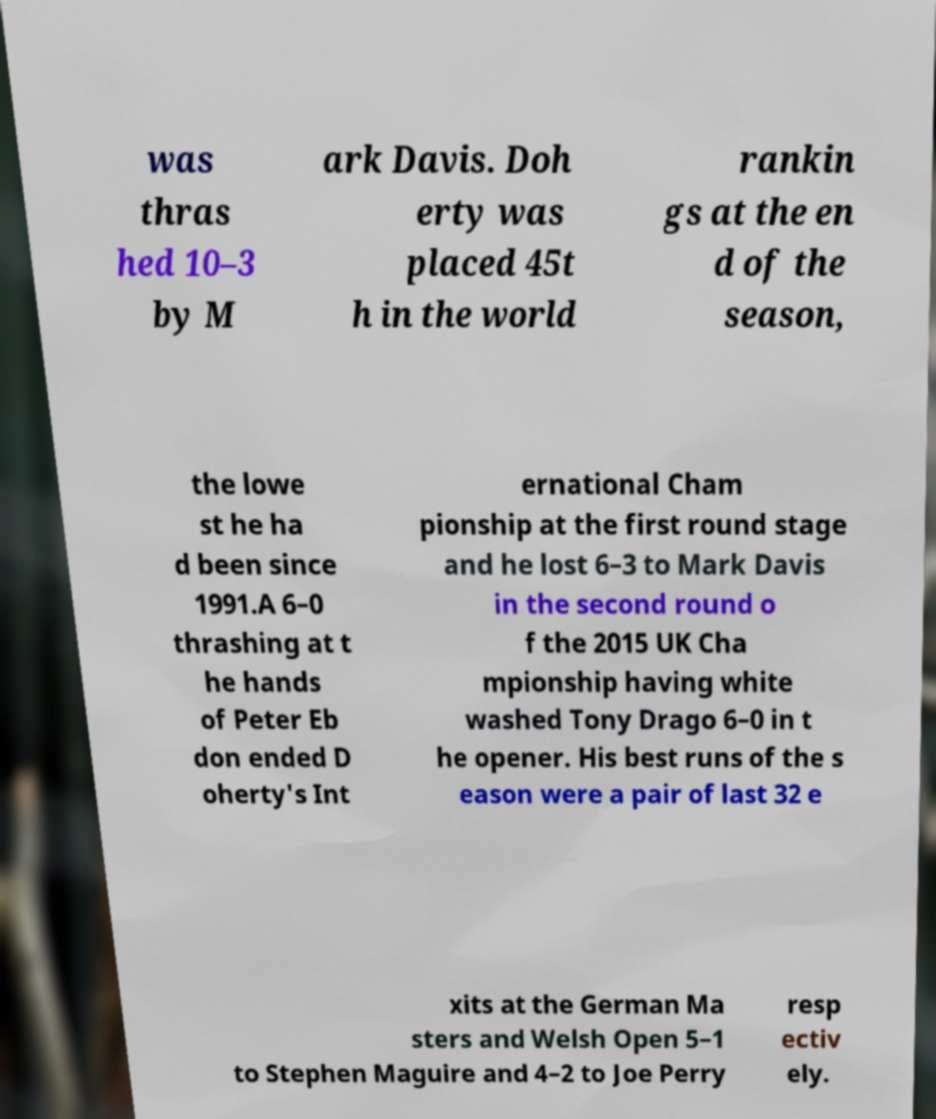There's text embedded in this image that I need extracted. Can you transcribe it verbatim? was thras hed 10–3 by M ark Davis. Doh erty was placed 45t h in the world rankin gs at the en d of the season, the lowe st he ha d been since 1991.A 6–0 thrashing at t he hands of Peter Eb don ended D oherty's Int ernational Cham pionship at the first round stage and he lost 6–3 to Mark Davis in the second round o f the 2015 UK Cha mpionship having white washed Tony Drago 6–0 in t he opener. His best runs of the s eason were a pair of last 32 e xits at the German Ma sters and Welsh Open 5–1 to Stephen Maguire and 4–2 to Joe Perry resp ectiv ely. 